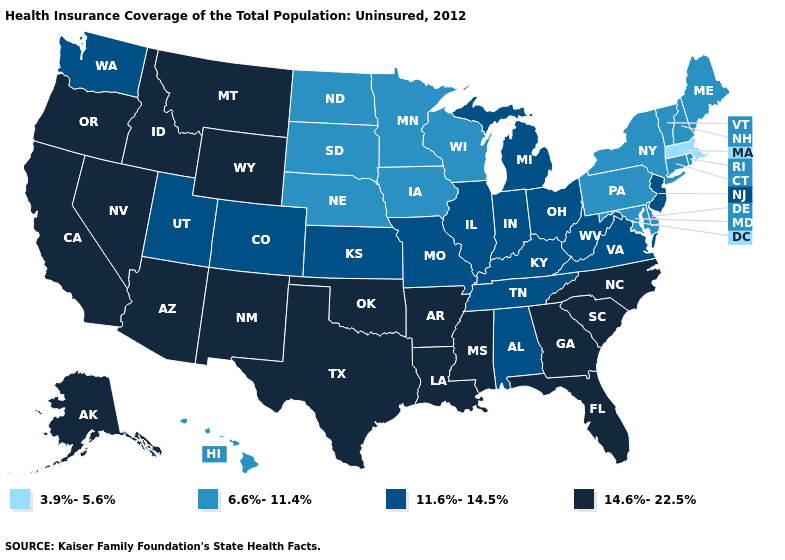Which states have the highest value in the USA?
Concise answer only. Alaska, Arizona, Arkansas, California, Florida, Georgia, Idaho, Louisiana, Mississippi, Montana, Nevada, New Mexico, North Carolina, Oklahoma, Oregon, South Carolina, Texas, Wyoming. What is the lowest value in the USA?
Keep it brief. 3.9%-5.6%. Does Kentucky have the highest value in the USA?
Quick response, please. No. Does the map have missing data?
Answer briefly. No. Name the states that have a value in the range 3.9%-5.6%?
Answer briefly. Massachusetts. Among the states that border Oklahoma , which have the lowest value?
Keep it brief. Colorado, Kansas, Missouri. What is the lowest value in the West?
Be succinct. 6.6%-11.4%. Does Arizona have the highest value in the USA?
Keep it brief. Yes. What is the highest value in states that border Vermont?
Short answer required. 6.6%-11.4%. Among the states that border Arizona , does California have the lowest value?
Keep it brief. No. How many symbols are there in the legend?
Be succinct. 4. Name the states that have a value in the range 11.6%-14.5%?
Quick response, please. Alabama, Colorado, Illinois, Indiana, Kansas, Kentucky, Michigan, Missouri, New Jersey, Ohio, Tennessee, Utah, Virginia, Washington, West Virginia. Among the states that border Michigan , does Wisconsin have the highest value?
Concise answer only. No. What is the lowest value in the USA?
Quick response, please. 3.9%-5.6%. 